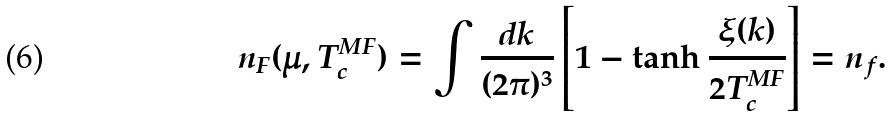Convert formula to latex. <formula><loc_0><loc_0><loc_500><loc_500>n _ { F } ( \mu , T _ { c } ^ { M F } ) = \int \frac { d { k } } { ( 2 \pi ) ^ { 3 } } \left [ 1 - \tanh \frac { \xi ( k ) } { 2 T _ { c } ^ { M F } } \right ] = n _ { f } .</formula> 